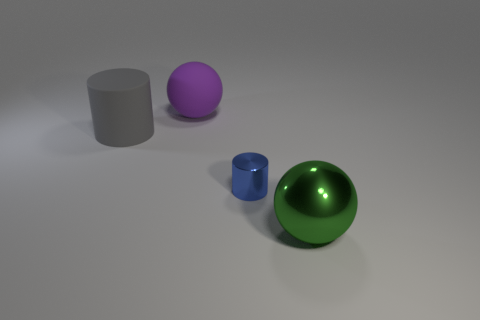Add 4 yellow metallic cylinders. How many objects exist? 8 Subtract 2 spheres. How many spheres are left? 0 Subtract all green balls. How many balls are left? 1 Subtract 0 red cubes. How many objects are left? 4 Subtract all red spheres. Subtract all purple cylinders. How many spheres are left? 2 Subtract all cyan cylinders. How many green balls are left? 1 Subtract all matte things. Subtract all big cylinders. How many objects are left? 1 Add 1 matte objects. How many matte objects are left? 3 Add 4 large green metal objects. How many large green metal objects exist? 5 